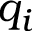Convert formula to latex. <formula><loc_0><loc_0><loc_500><loc_500>q _ { i }</formula> 